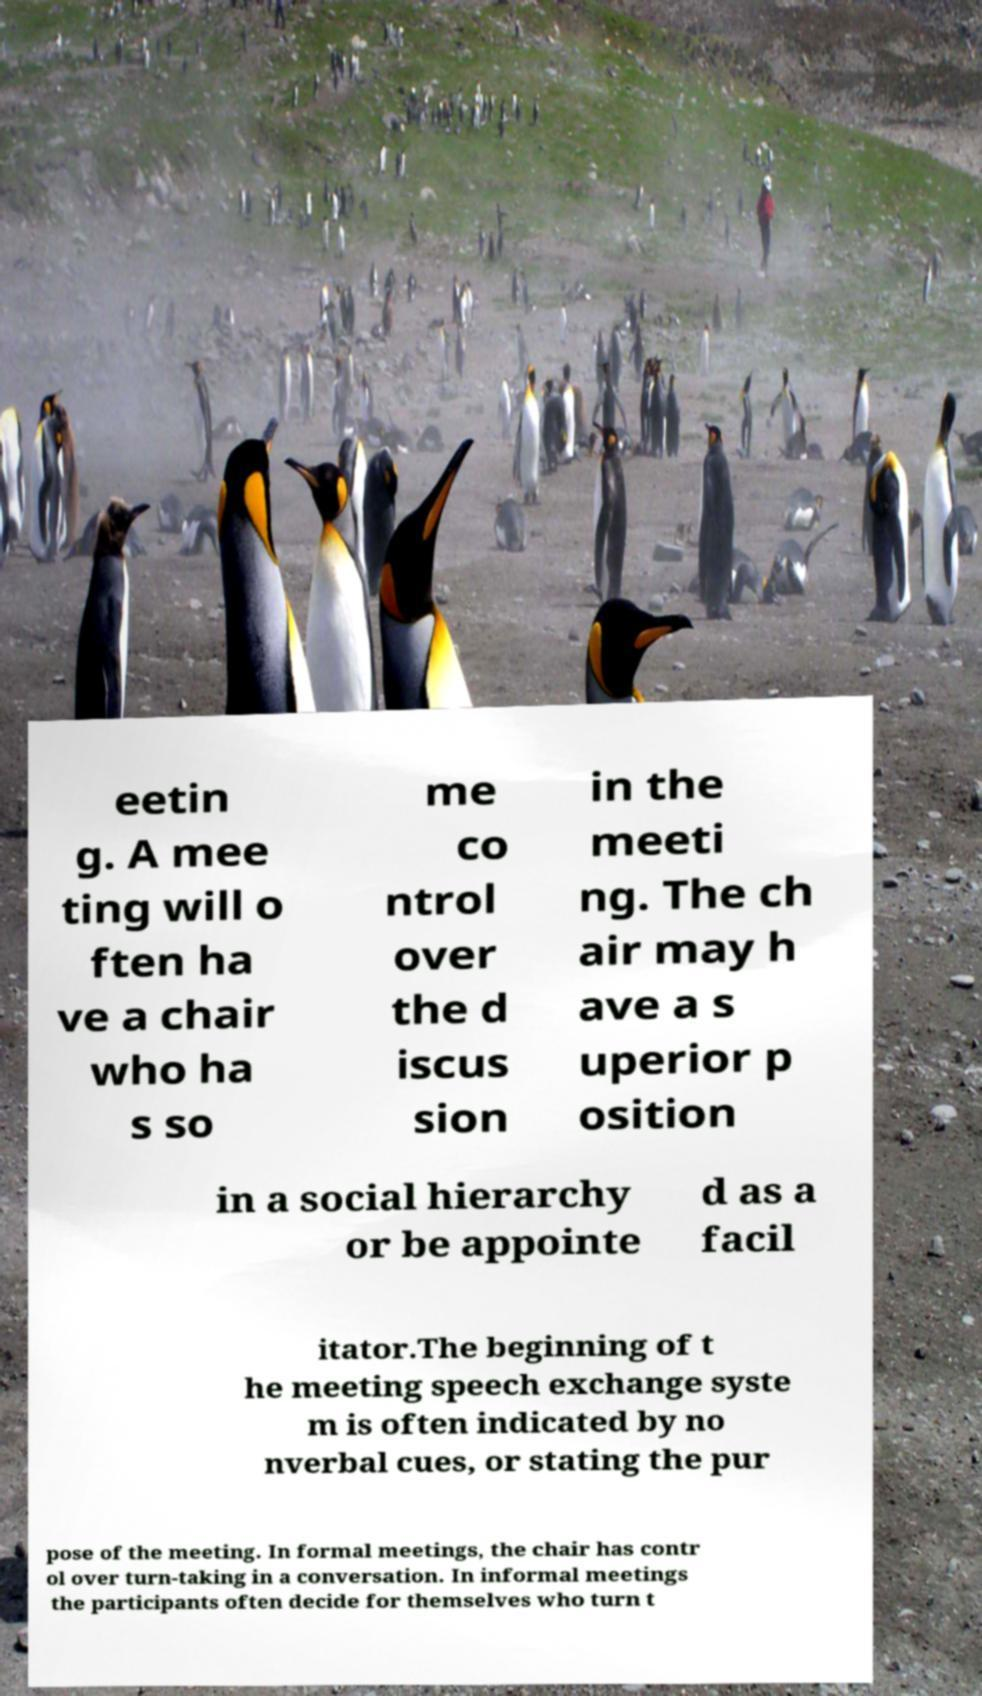For documentation purposes, I need the text within this image transcribed. Could you provide that? eetin g. A mee ting will o ften ha ve a chair who ha s so me co ntrol over the d iscus sion in the meeti ng. The ch air may h ave a s uperior p osition in a social hierarchy or be appointe d as a facil itator.The beginning of t he meeting speech exchange syste m is often indicated by no nverbal cues, or stating the pur pose of the meeting. In formal meetings, the chair has contr ol over turn-taking in a conversation. In informal meetings the participants often decide for themselves who turn t 